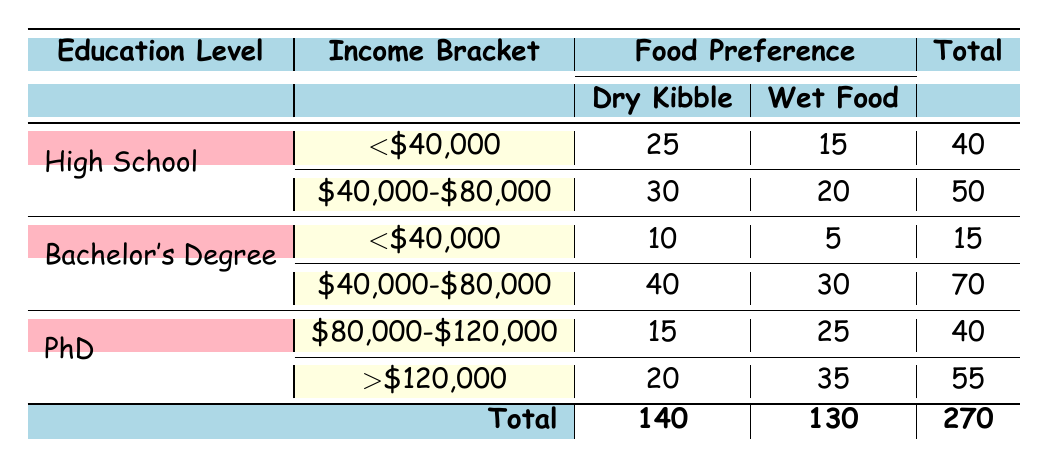What is the total number of owners who prefer Wet Food? To find this, we sum the counts of Wet Food in the table across all education levels and income brackets. The values are 15 (High School <$40,000) + 20 (High School $40,000-$80,000) + 5 (Bachelor's <$40,000) + 30 (Bachelor's $40,000-$80,000) + 25 (PhD $80,000-$120,000) + 35 (PhD >$120,000) = 130.
Answer: 130 How many High School educated owners prefer Dry Kibble? Looking at the table, there are two entries for High School: one for income bracket <$40,000 (25 owners) and another for $40,000-$80,000 (30 owners). The total for Dry Kibble in this category is 25 + 30 = 55.
Answer: 55 Is Dry Kibble more popular than Wet Food among Bachelor's degree holders in the income bracket $40,000-$80,000? For Bachelor's degree holders in the $40,000-$80,000 bracket, the count for Dry Kibble is 40, while for Wet Food it is 30. Since 40 is greater than 30, the answer is yes.
Answer: Yes What is the total count of owners with a PhD who prefer Wet Food? We look at the PhD category in the table, noting that there are 25 owners who prefer Wet Food in the $80,000-$120,000 bracket and 35 owners in the >$120,000 bracket. Summing these gives 25 + 35 = 60.
Answer: 60 Among all education levels, what percentage of owners prefer Dry Kibble? To find the percentage, we first sum the total counts of Dry Kibble. This comes to 140 (Dry Kibble total from the table). The total number of dog owners surveyed is 270. Hence, the percentage is (140 / 270) * 100 ≈ 51.85%.
Answer: 51.85% How many owners with a Bachelor's degree prefer Wet Food in the <$40,000 income bracket? From the table, we see that there are 5 owners with a Bachelor's degree in the income bracket <$40,000 who prefer Wet Food. This value comes directly from the corresponding cell in the table.
Answer: 5 If we compare preferences for Dry Kibble between High School and PhD holders in the income bracket >$120,000, who has a higher preference? For High School holders in the >$120,000 bracket, there are no holders listed, while for PhD holders in this category, there are 20 who prefer Dry Kibble. Hence, PhD holders have a higher preference for Dry Kibble.
Answer: PhD holders What is the overall difference in counts between owners who prefer Dry Kibble and those who prefer Wet Food? We find the total for both preferences: Dry Kibble is 140 and Wet Food is 130 from the table. Therefore, we subtract: 140 - 130 = 10.
Answer: 10 How many owners with a PhD but earning <$40,000 prefer Dry Kibble? According to the table, there are no entries for PhD holders earning <$40,000, which means the count is 0.
Answer: 0 